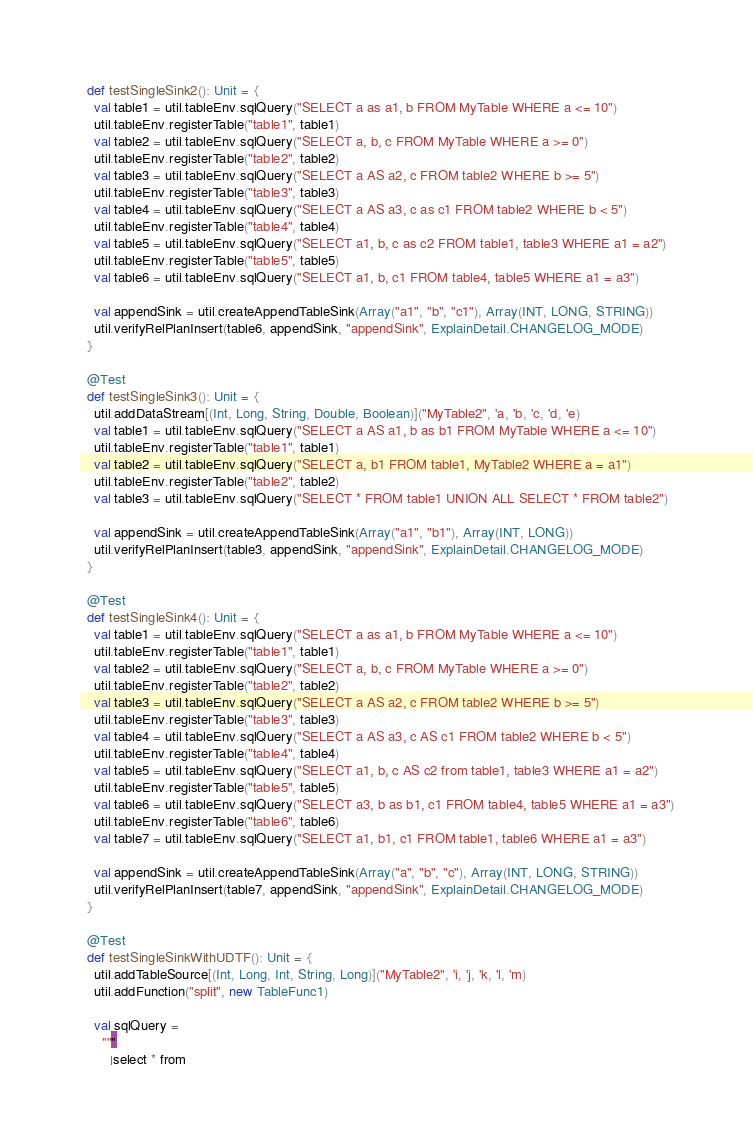<code> <loc_0><loc_0><loc_500><loc_500><_Scala_>  def testSingleSink2(): Unit = {
    val table1 = util.tableEnv.sqlQuery("SELECT a as a1, b FROM MyTable WHERE a <= 10")
    util.tableEnv.registerTable("table1", table1)
    val table2 = util.tableEnv.sqlQuery("SELECT a, b, c FROM MyTable WHERE a >= 0")
    util.tableEnv.registerTable("table2", table2)
    val table3 = util.tableEnv.sqlQuery("SELECT a AS a2, c FROM table2 WHERE b >= 5")
    util.tableEnv.registerTable("table3", table3)
    val table4 = util.tableEnv.sqlQuery("SELECT a AS a3, c as c1 FROM table2 WHERE b < 5")
    util.tableEnv.registerTable("table4", table4)
    val table5 = util.tableEnv.sqlQuery("SELECT a1, b, c as c2 FROM table1, table3 WHERE a1 = a2")
    util.tableEnv.registerTable("table5", table5)
    val table6 = util.tableEnv.sqlQuery("SELECT a1, b, c1 FROM table4, table5 WHERE a1 = a3")

    val appendSink = util.createAppendTableSink(Array("a1", "b", "c1"), Array(INT, LONG, STRING))
    util.verifyRelPlanInsert(table6, appendSink, "appendSink", ExplainDetail.CHANGELOG_MODE)
  }

  @Test
  def testSingleSink3(): Unit = {
    util.addDataStream[(Int, Long, String, Double, Boolean)]("MyTable2", 'a, 'b, 'c, 'd, 'e)
    val table1 = util.tableEnv.sqlQuery("SELECT a AS a1, b as b1 FROM MyTable WHERE a <= 10")
    util.tableEnv.registerTable("table1", table1)
    val table2 = util.tableEnv.sqlQuery("SELECT a, b1 FROM table1, MyTable2 WHERE a = a1")
    util.tableEnv.registerTable("table2", table2)
    val table3 = util.tableEnv.sqlQuery("SELECT * FROM table1 UNION ALL SELECT * FROM table2")

    val appendSink = util.createAppendTableSink(Array("a1", "b1"), Array(INT, LONG))
    util.verifyRelPlanInsert(table3, appendSink, "appendSink", ExplainDetail.CHANGELOG_MODE)
  }

  @Test
  def testSingleSink4(): Unit = {
    val table1 = util.tableEnv.sqlQuery("SELECT a as a1, b FROM MyTable WHERE a <= 10")
    util.tableEnv.registerTable("table1", table1)
    val table2 = util.tableEnv.sqlQuery("SELECT a, b, c FROM MyTable WHERE a >= 0")
    util.tableEnv.registerTable("table2", table2)
    val table3 = util.tableEnv.sqlQuery("SELECT a AS a2, c FROM table2 WHERE b >= 5")
    util.tableEnv.registerTable("table3", table3)
    val table4 = util.tableEnv.sqlQuery("SELECT a AS a3, c AS c1 FROM table2 WHERE b < 5")
    util.tableEnv.registerTable("table4", table4)
    val table5 = util.tableEnv.sqlQuery("SELECT a1, b, c AS c2 from table1, table3 WHERE a1 = a2")
    util.tableEnv.registerTable("table5", table5)
    val table6 = util.tableEnv.sqlQuery("SELECT a3, b as b1, c1 FROM table4, table5 WHERE a1 = a3")
    util.tableEnv.registerTable("table6", table6)
    val table7 = util.tableEnv.sqlQuery("SELECT a1, b1, c1 FROM table1, table6 WHERE a1 = a3")

    val appendSink = util.createAppendTableSink(Array("a", "b", "c"), Array(INT, LONG, STRING))
    util.verifyRelPlanInsert(table7, appendSink, "appendSink", ExplainDetail.CHANGELOG_MODE)
  }

  @Test
  def testSingleSinkWithUDTF(): Unit = {
    util.addTableSource[(Int, Long, Int, String, Long)]("MyTable2", 'i, 'j, 'k, 'l, 'm)
    util.addFunction("split", new TableFunc1)

    val sqlQuery =
      """
        |select * from</code> 